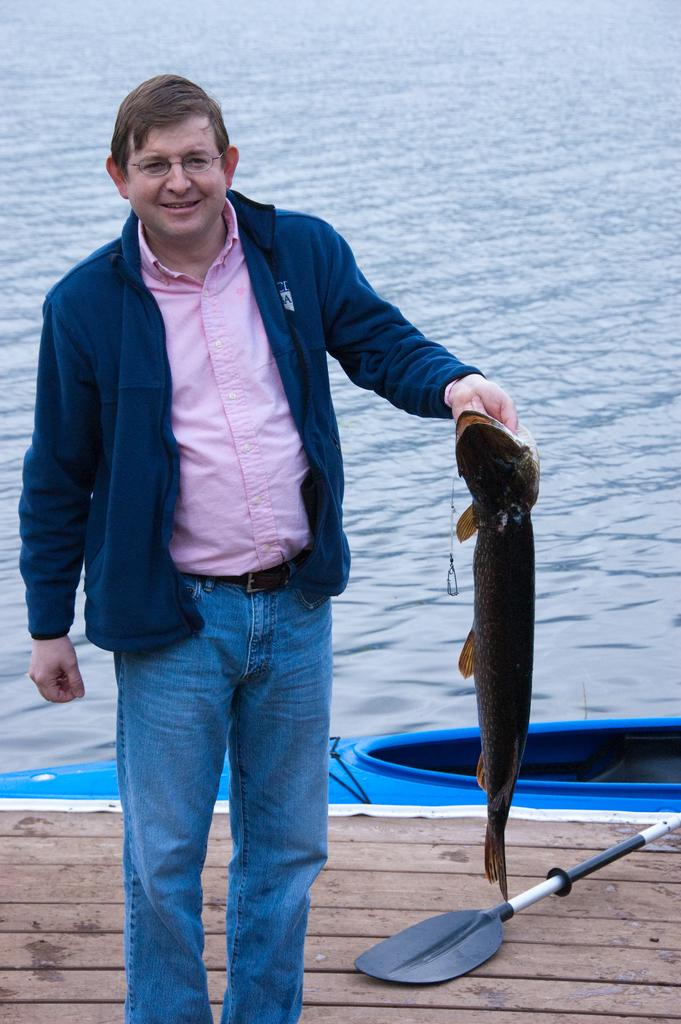Who is present in the image? There is a man in the image. What is the man doing in the image? The man is standing in the image. What is the man wearing in the image? The man is wearing a blue sweater in the image. What is the man holding in his left hand in the image? The man is holding a fish in his left hand in the image. What can be seen behind the man in the image? There is water visible behind the man in the image. Where is the crowd of people gathered in the image? There is no crowd of people present in the image. What type of creature is swimming in the water behind the man in the image? There is no creature visible in the water behind the man in the image. 